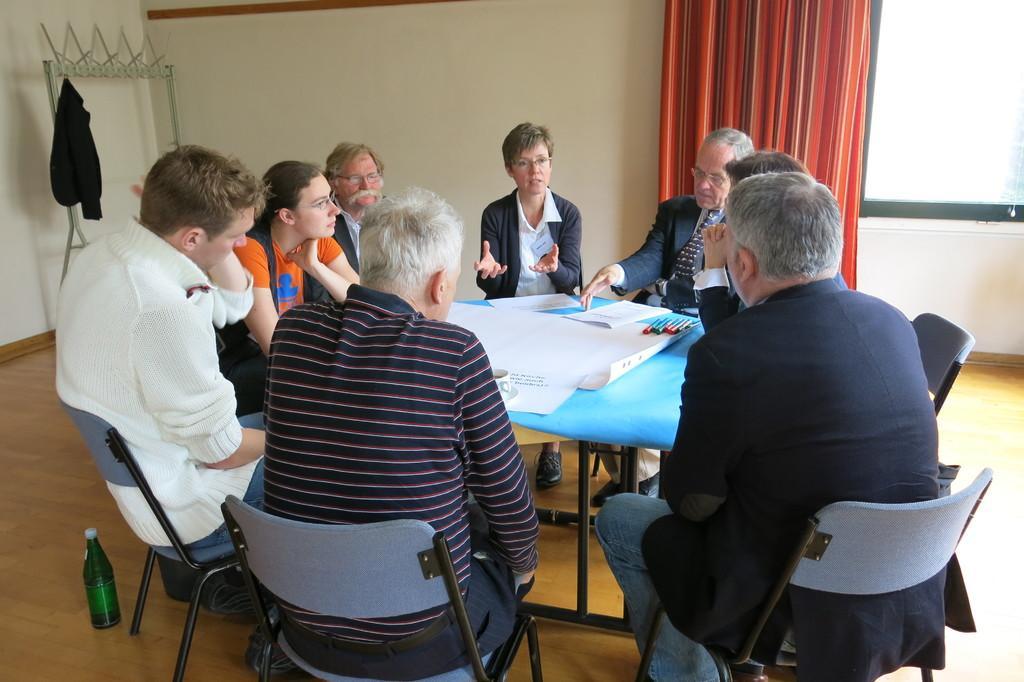How would you summarize this image in a sentence or two? In the image we can see there are people who are sitting on the chair and in front of them there is a table on which there are white charts and marker pens and at the back the curtain is in red colour and there is a water bottle on the floor. 